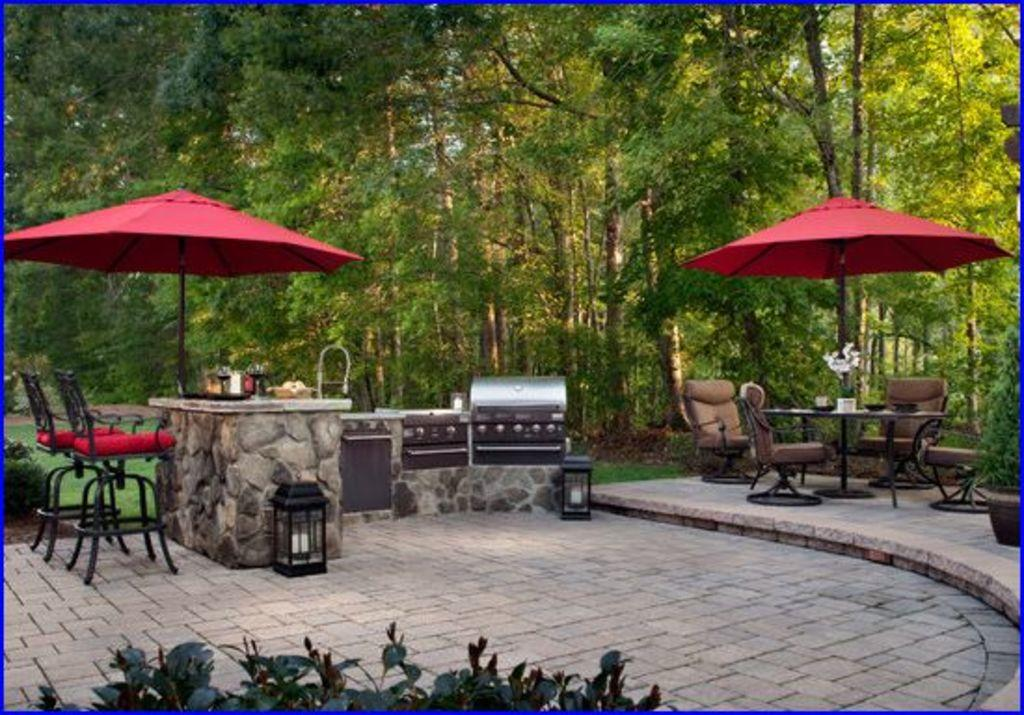What type of furniture is visible in the image? There are chairs and tables in the image. What can be used for shade in the image? There are umbrellas in the image. What type of natural elements are present in the image? There are trees in the image. What part of the environment is visible in the image? The ground is visible in the image. What is present on the ground in the image? There are objects on the ground. What is present at the bottom of the image? Leaves are present at the bottom of the image. What nation is represented by the flag on the umbrella in the image? There is no flag present on the umbrella in the image. What type of poisonous substance is present in the image? There is no poisonous substance present in the image. 